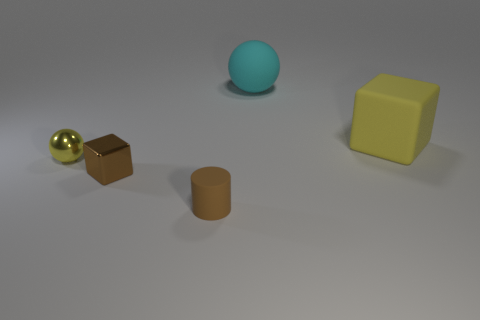What number of other objects are there of the same size as the cyan rubber sphere?
Your answer should be very brief. 1. What number of large objects are either yellow objects or yellow blocks?
Your answer should be very brief. 1. There is a tiny object that is to the left of the brown cylinder and to the right of the yellow metallic object; what material is it?
Your answer should be very brief. Metal. Is the shape of the tiny shiny object in front of the small ball the same as the small brown object on the right side of the small shiny cube?
Your answer should be compact. No. There is a metallic thing that is the same color as the matte cylinder; what is its shape?
Your response must be concise. Cube. How many things are either yellow objects that are to the left of the yellow rubber object or matte balls?
Make the answer very short. 2. Is the size of the matte cylinder the same as the shiny ball?
Your response must be concise. Yes. The big rubber object to the right of the big ball is what color?
Give a very brief answer. Yellow. There is a brown cylinder that is made of the same material as the large cyan ball; what size is it?
Ensure brevity in your answer.  Small. There is a cylinder; does it have the same size as the rubber thing that is right of the big matte ball?
Your answer should be compact. No. 